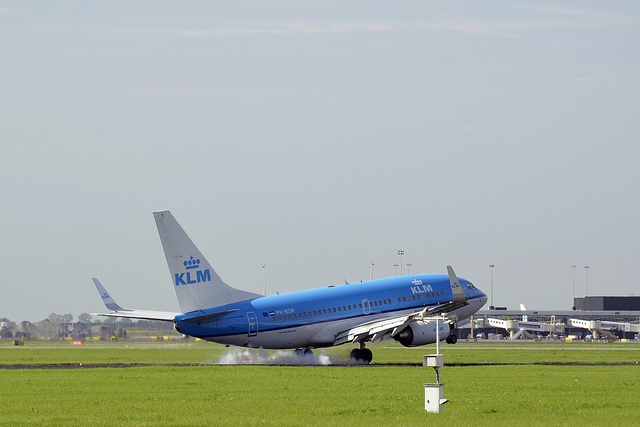Describe the objects in this image and their specific colors. I can see a airplane in lightgray, blue, darkgray, gray, and black tones in this image. 